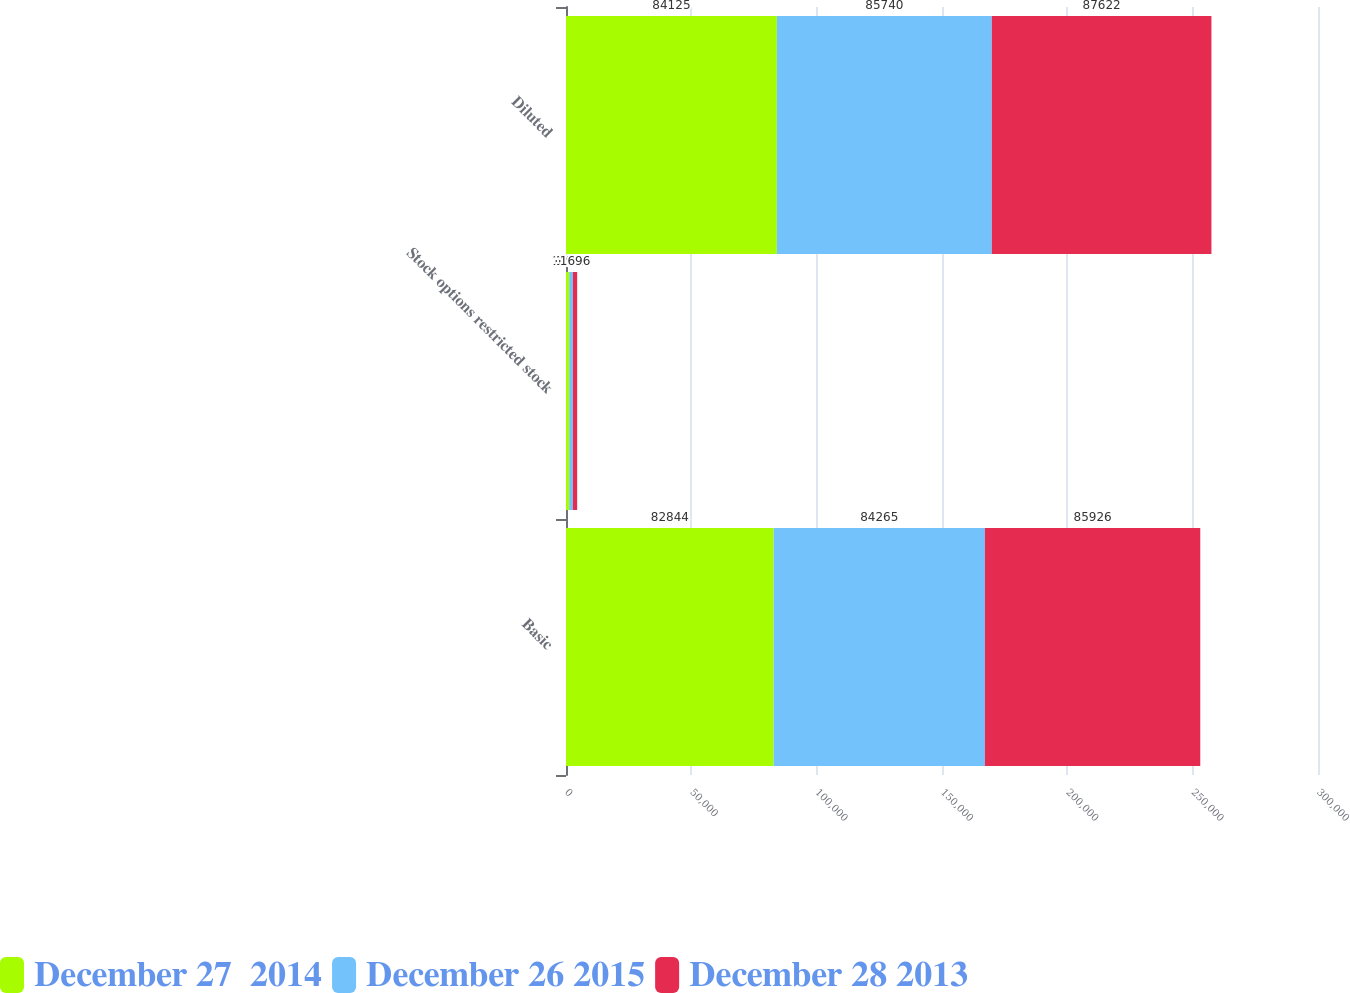Convert chart to OTSL. <chart><loc_0><loc_0><loc_500><loc_500><stacked_bar_chart><ecel><fcel>Basic<fcel>Stock options restricted stock<fcel>Diluted<nl><fcel>December 27  2014<fcel>82844<fcel>1281<fcel>84125<nl><fcel>December 26 2015<fcel>84265<fcel>1475<fcel>85740<nl><fcel>December 28 2013<fcel>85926<fcel>1696<fcel>87622<nl></chart> 